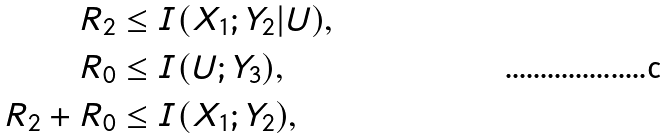<formula> <loc_0><loc_0><loc_500><loc_500>R _ { 2 } & \leq I ( X _ { 1 } ; Y _ { 2 } | U ) , \\ R _ { 0 } & \leq I ( U ; Y _ { 3 } ) , \\ R _ { 2 } + R _ { 0 } & \leq I ( X _ { 1 } ; Y _ { 2 } ) ,</formula> 